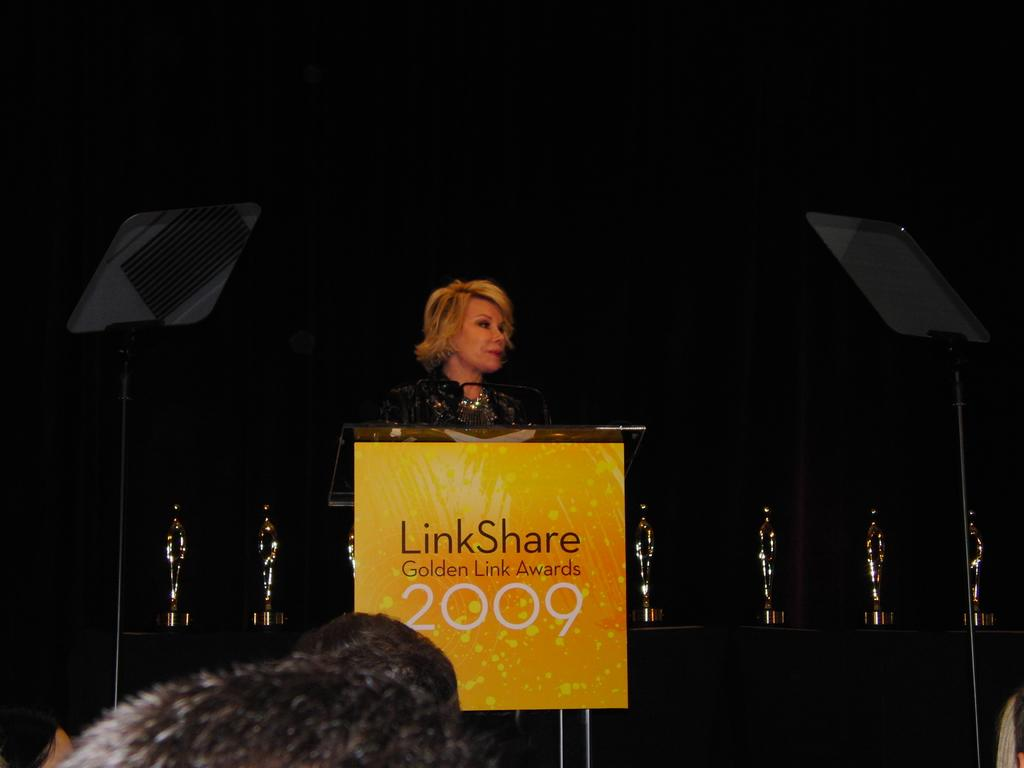Who is the main subject in the image? There is a woman in the image. What is the woman doing in the image? The woman is standing behind a podium and holding a microphone. Are there any other people visible in the image? Yes, there are people at the bottom of the image. What objects can be seen on the table behind the woman? There are shields on a table behind the woman. What type of muscle is being exercised by the woman in the image? There is no indication in the image that the woman is exercising any muscles, as she is standing behind a podium and holding a microphone. 